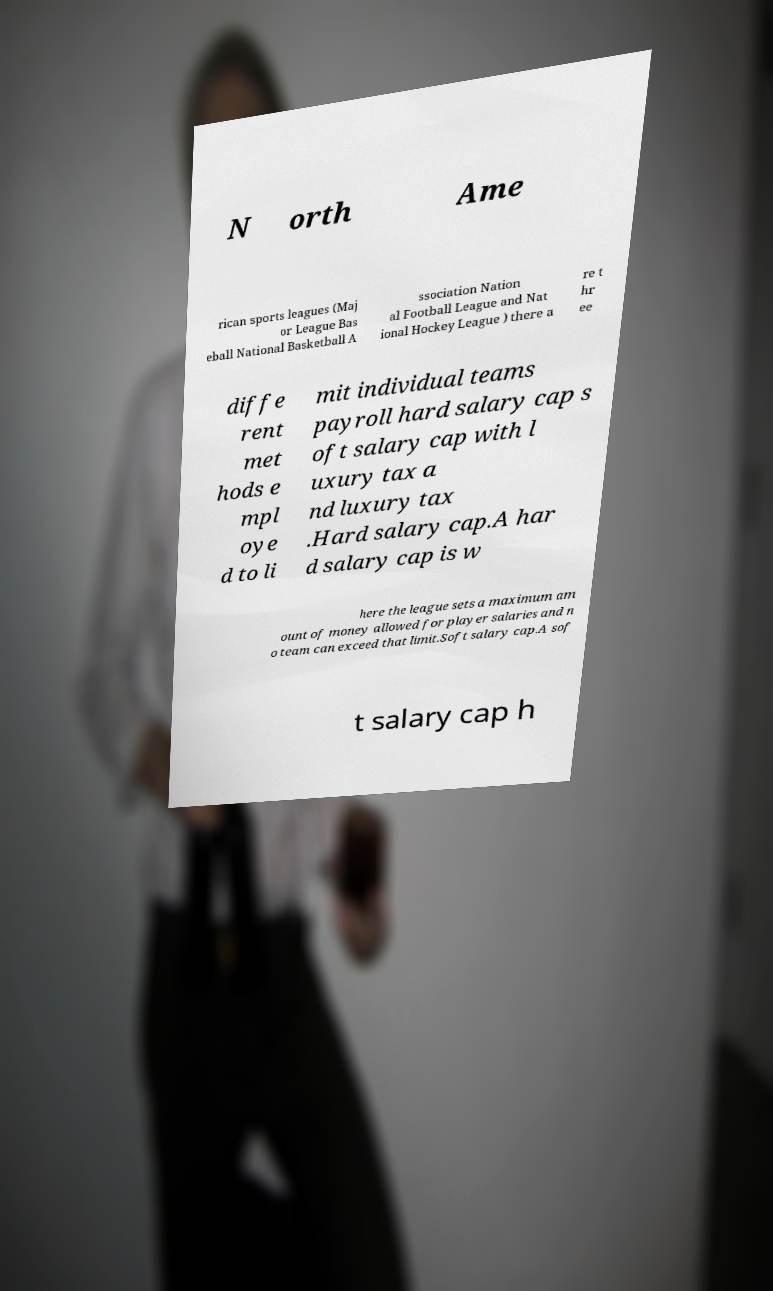Could you assist in decoding the text presented in this image and type it out clearly? N orth Ame rican sports leagues (Maj or League Bas eball National Basketball A ssociation Nation al Football League and Nat ional Hockey League ) there a re t hr ee diffe rent met hods e mpl oye d to li mit individual teams payroll hard salary cap s oft salary cap with l uxury tax a nd luxury tax .Hard salary cap.A har d salary cap is w here the league sets a maximum am ount of money allowed for player salaries and n o team can exceed that limit.Soft salary cap.A sof t salary cap h 